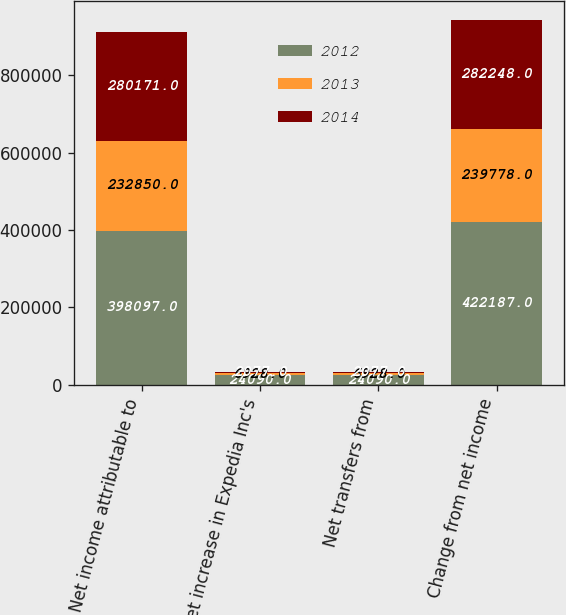Convert chart to OTSL. <chart><loc_0><loc_0><loc_500><loc_500><stacked_bar_chart><ecel><fcel>Net income attributable to<fcel>Net increase in Expedia Inc's<fcel>Net transfers from<fcel>Change from net income<nl><fcel>2012<fcel>398097<fcel>24090<fcel>24090<fcel>422187<nl><fcel>2013<fcel>232850<fcel>6928<fcel>6928<fcel>239778<nl><fcel>2014<fcel>280171<fcel>2077<fcel>2077<fcel>282248<nl></chart> 